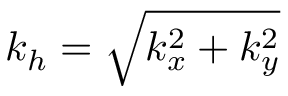<formula> <loc_0><loc_0><loc_500><loc_500>k _ { h } = \sqrt { k _ { x } ^ { 2 } + k _ { y } ^ { 2 } }</formula> 